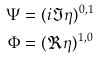<formula> <loc_0><loc_0><loc_500><loc_500>\Psi & = ( i \Im \eta ) ^ { 0 , 1 } \\ \Phi & = ( \Re \eta ) ^ { 1 , 0 }</formula> 